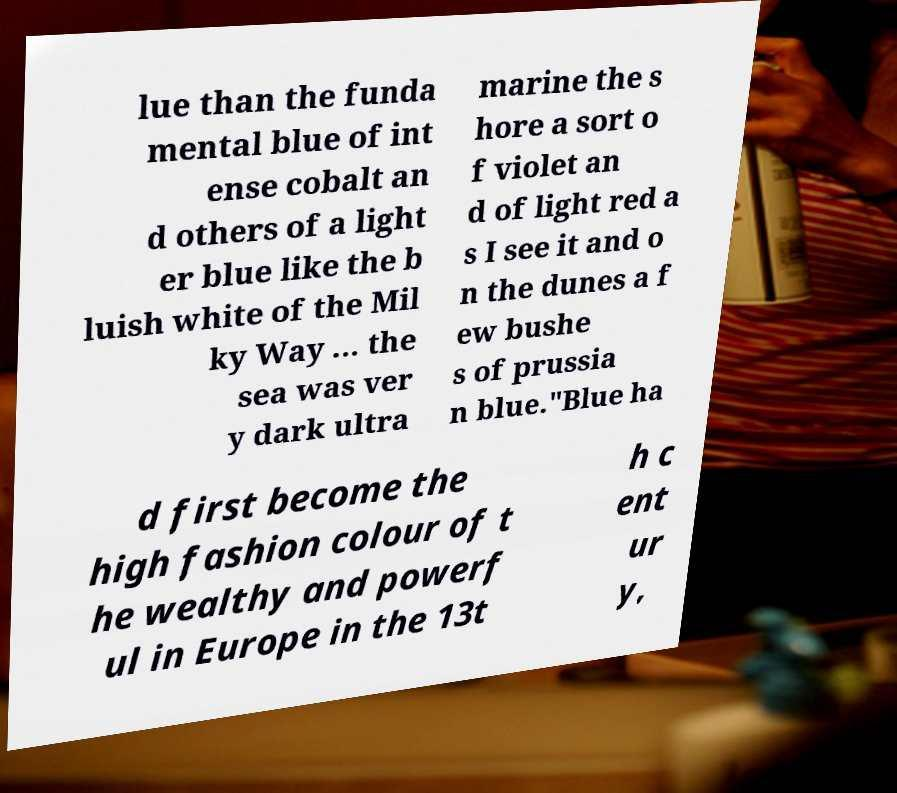Could you extract and type out the text from this image? lue than the funda mental blue of int ense cobalt an d others of a light er blue like the b luish white of the Mil ky Way ... the sea was ver y dark ultra marine the s hore a sort o f violet an d of light red a s I see it and o n the dunes a f ew bushe s of prussia n blue."Blue ha d first become the high fashion colour of t he wealthy and powerf ul in Europe in the 13t h c ent ur y, 